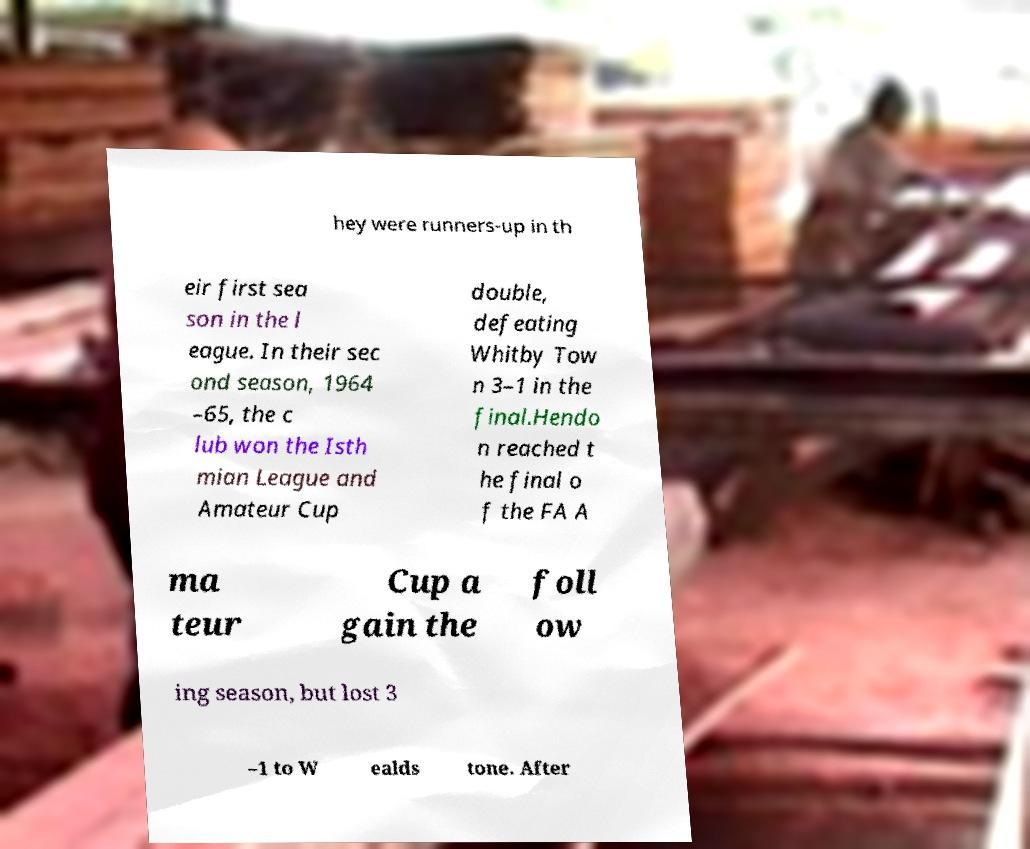Could you assist in decoding the text presented in this image and type it out clearly? hey were runners-up in th eir first sea son in the l eague. In their sec ond season, 1964 –65, the c lub won the Isth mian League and Amateur Cup double, defeating Whitby Tow n 3–1 in the final.Hendo n reached t he final o f the FA A ma teur Cup a gain the foll ow ing season, but lost 3 –1 to W ealds tone. After 